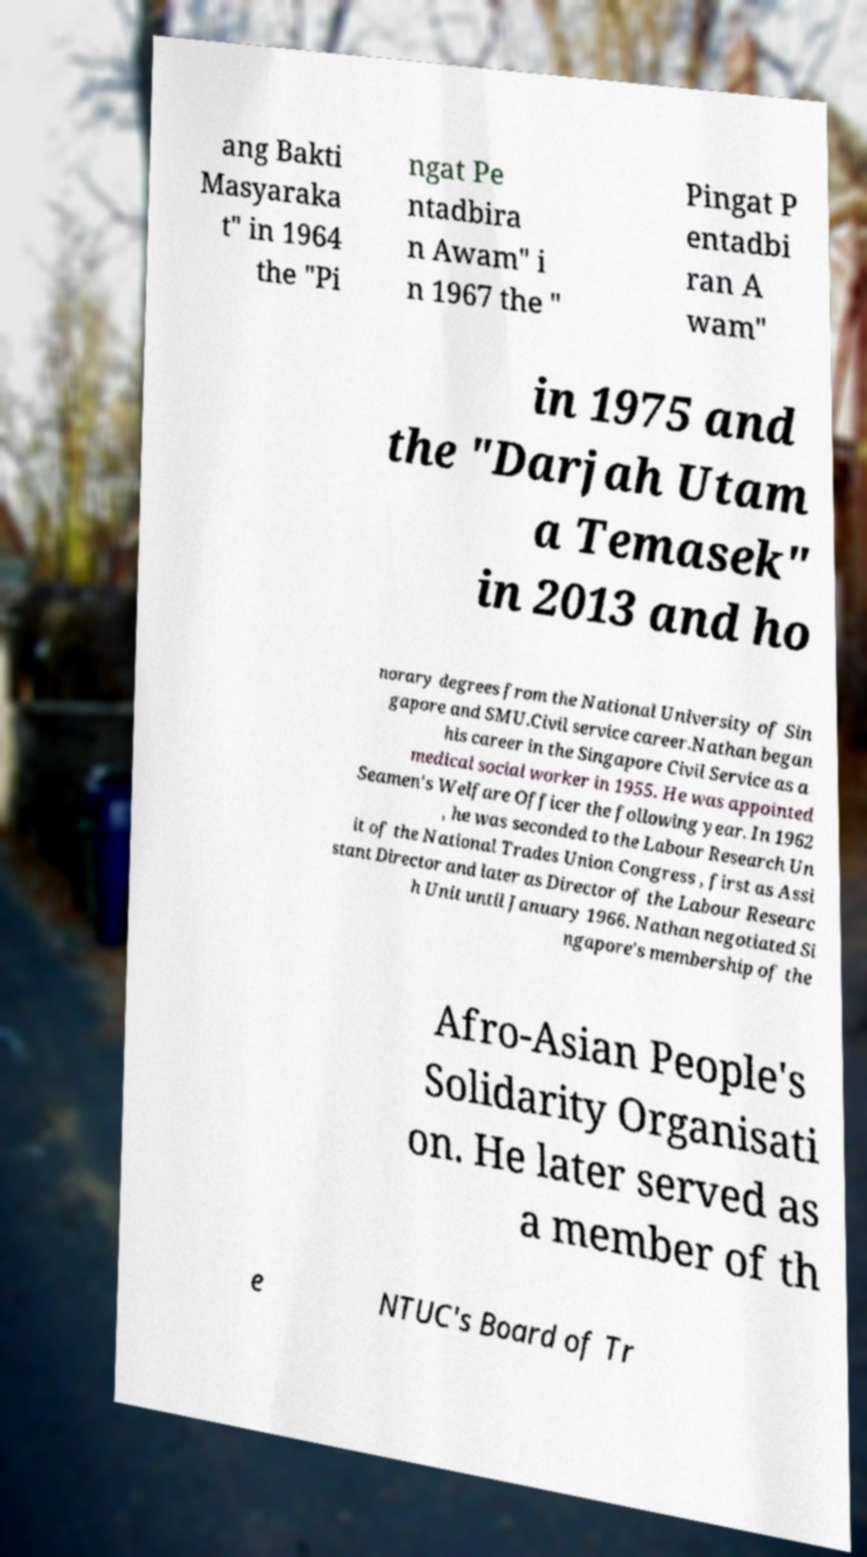What messages or text are displayed in this image? I need them in a readable, typed format. ang Bakti Masyaraka t" in 1964 the "Pi ngat Pe ntadbira n Awam" i n 1967 the " Pingat P entadbi ran A wam" in 1975 and the "Darjah Utam a Temasek" in 2013 and ho norary degrees from the National University of Sin gapore and SMU.Civil service career.Nathan began his career in the Singapore Civil Service as a medical social worker in 1955. He was appointed Seamen's Welfare Officer the following year. In 1962 , he was seconded to the Labour Research Un it of the National Trades Union Congress , first as Assi stant Director and later as Director of the Labour Researc h Unit until January 1966. Nathan negotiated Si ngapore's membership of the Afro-Asian People's Solidarity Organisati on. He later served as a member of th e NTUC's Board of Tr 